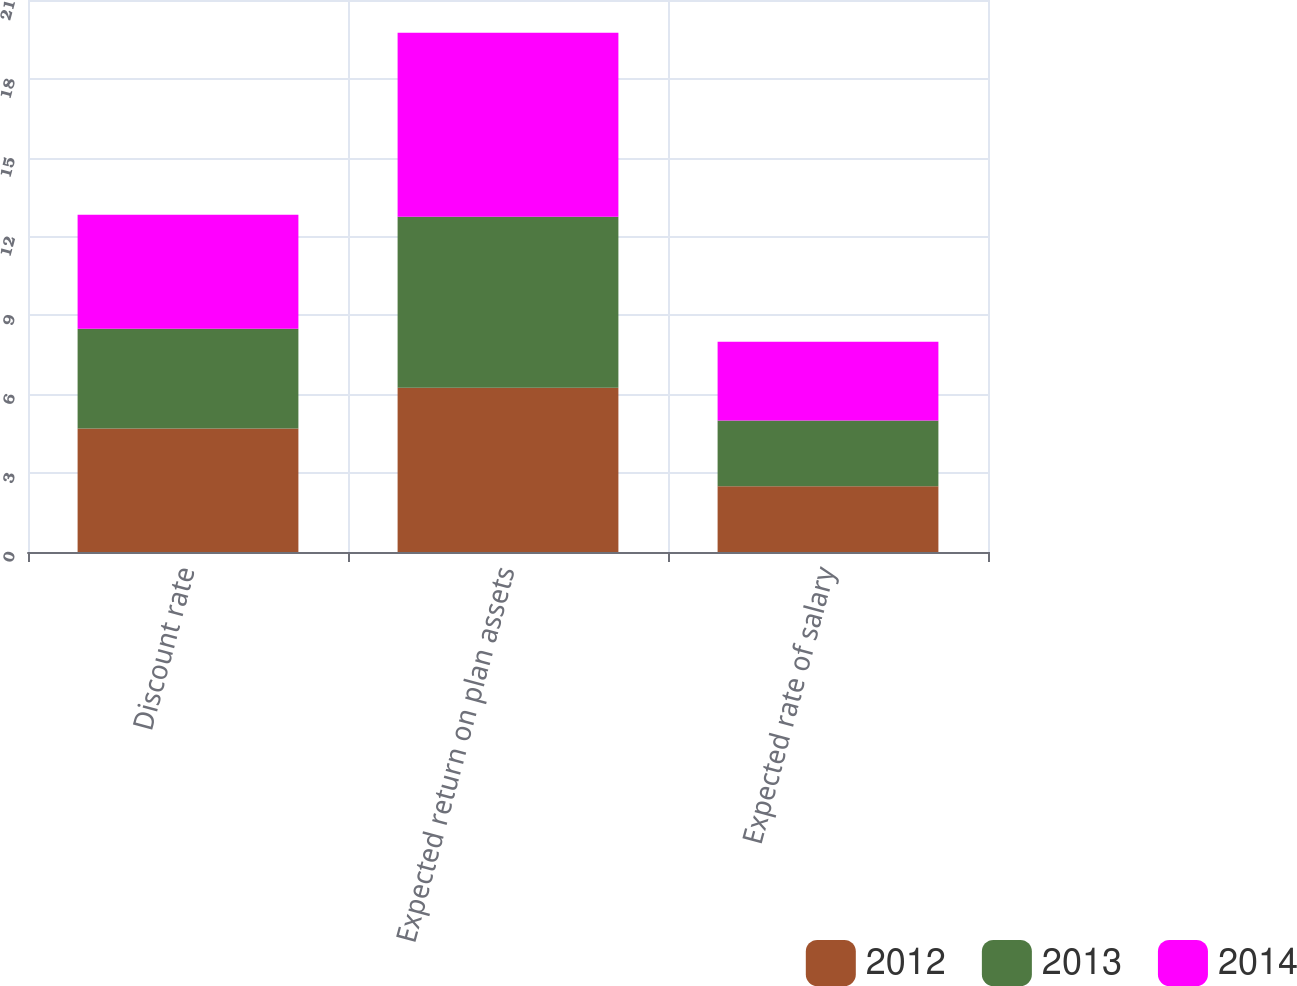<chart> <loc_0><loc_0><loc_500><loc_500><stacked_bar_chart><ecel><fcel>Discount rate<fcel>Expected return on plan assets<fcel>Expected rate of salary<nl><fcel>2012<fcel>4.7<fcel>6.25<fcel>2.5<nl><fcel>2013<fcel>3.79<fcel>6.5<fcel>2.5<nl><fcel>2014<fcel>4.34<fcel>7<fcel>3<nl></chart> 